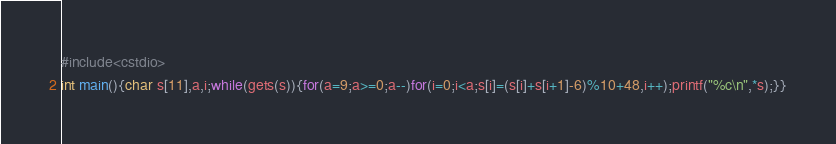Convert code to text. <code><loc_0><loc_0><loc_500><loc_500><_C++_>#include<cstdio>
int main(){char s[11],a,i;while(gets(s)){for(a=9;a>=0;a--)for(i=0;i<a;s[i]=(s[i]+s[i+1]-6)%10+48,i++);printf("%c\n",*s);}}</code> 